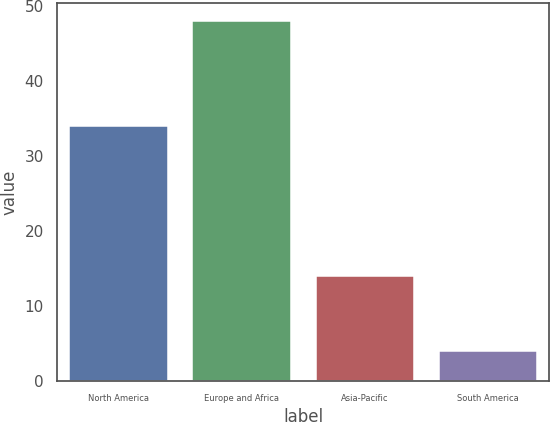Convert chart to OTSL. <chart><loc_0><loc_0><loc_500><loc_500><bar_chart><fcel>North America<fcel>Europe and Africa<fcel>Asia-Pacific<fcel>South America<nl><fcel>34<fcel>48<fcel>14<fcel>4<nl></chart> 